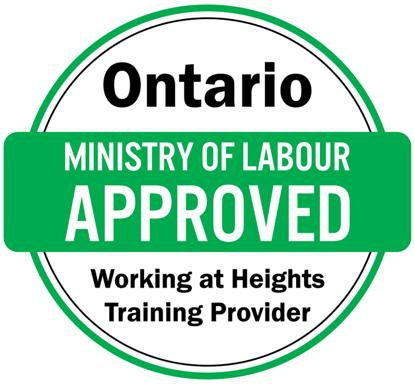How does this training impact the overall safety culture within construction industries in Ontario? This training significantly impacts the safety culture within Ontario's construction industries by raising awareness about the risks associated with working at heights and instilling a proactive approach to safety. It creates a standardized safety practice across all levels of operation, which helps reduce workplace accidents and fatalities. 